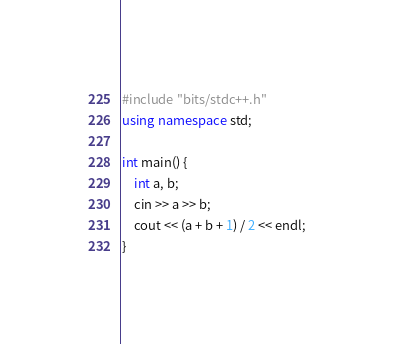Convert code to text. <code><loc_0><loc_0><loc_500><loc_500><_C++_>#include "bits/stdc++.h"
using namespace std;

int main() {
	int a, b;
	cin >> a >> b;
	cout << (a + b + 1) / 2 << endl;
}</code> 